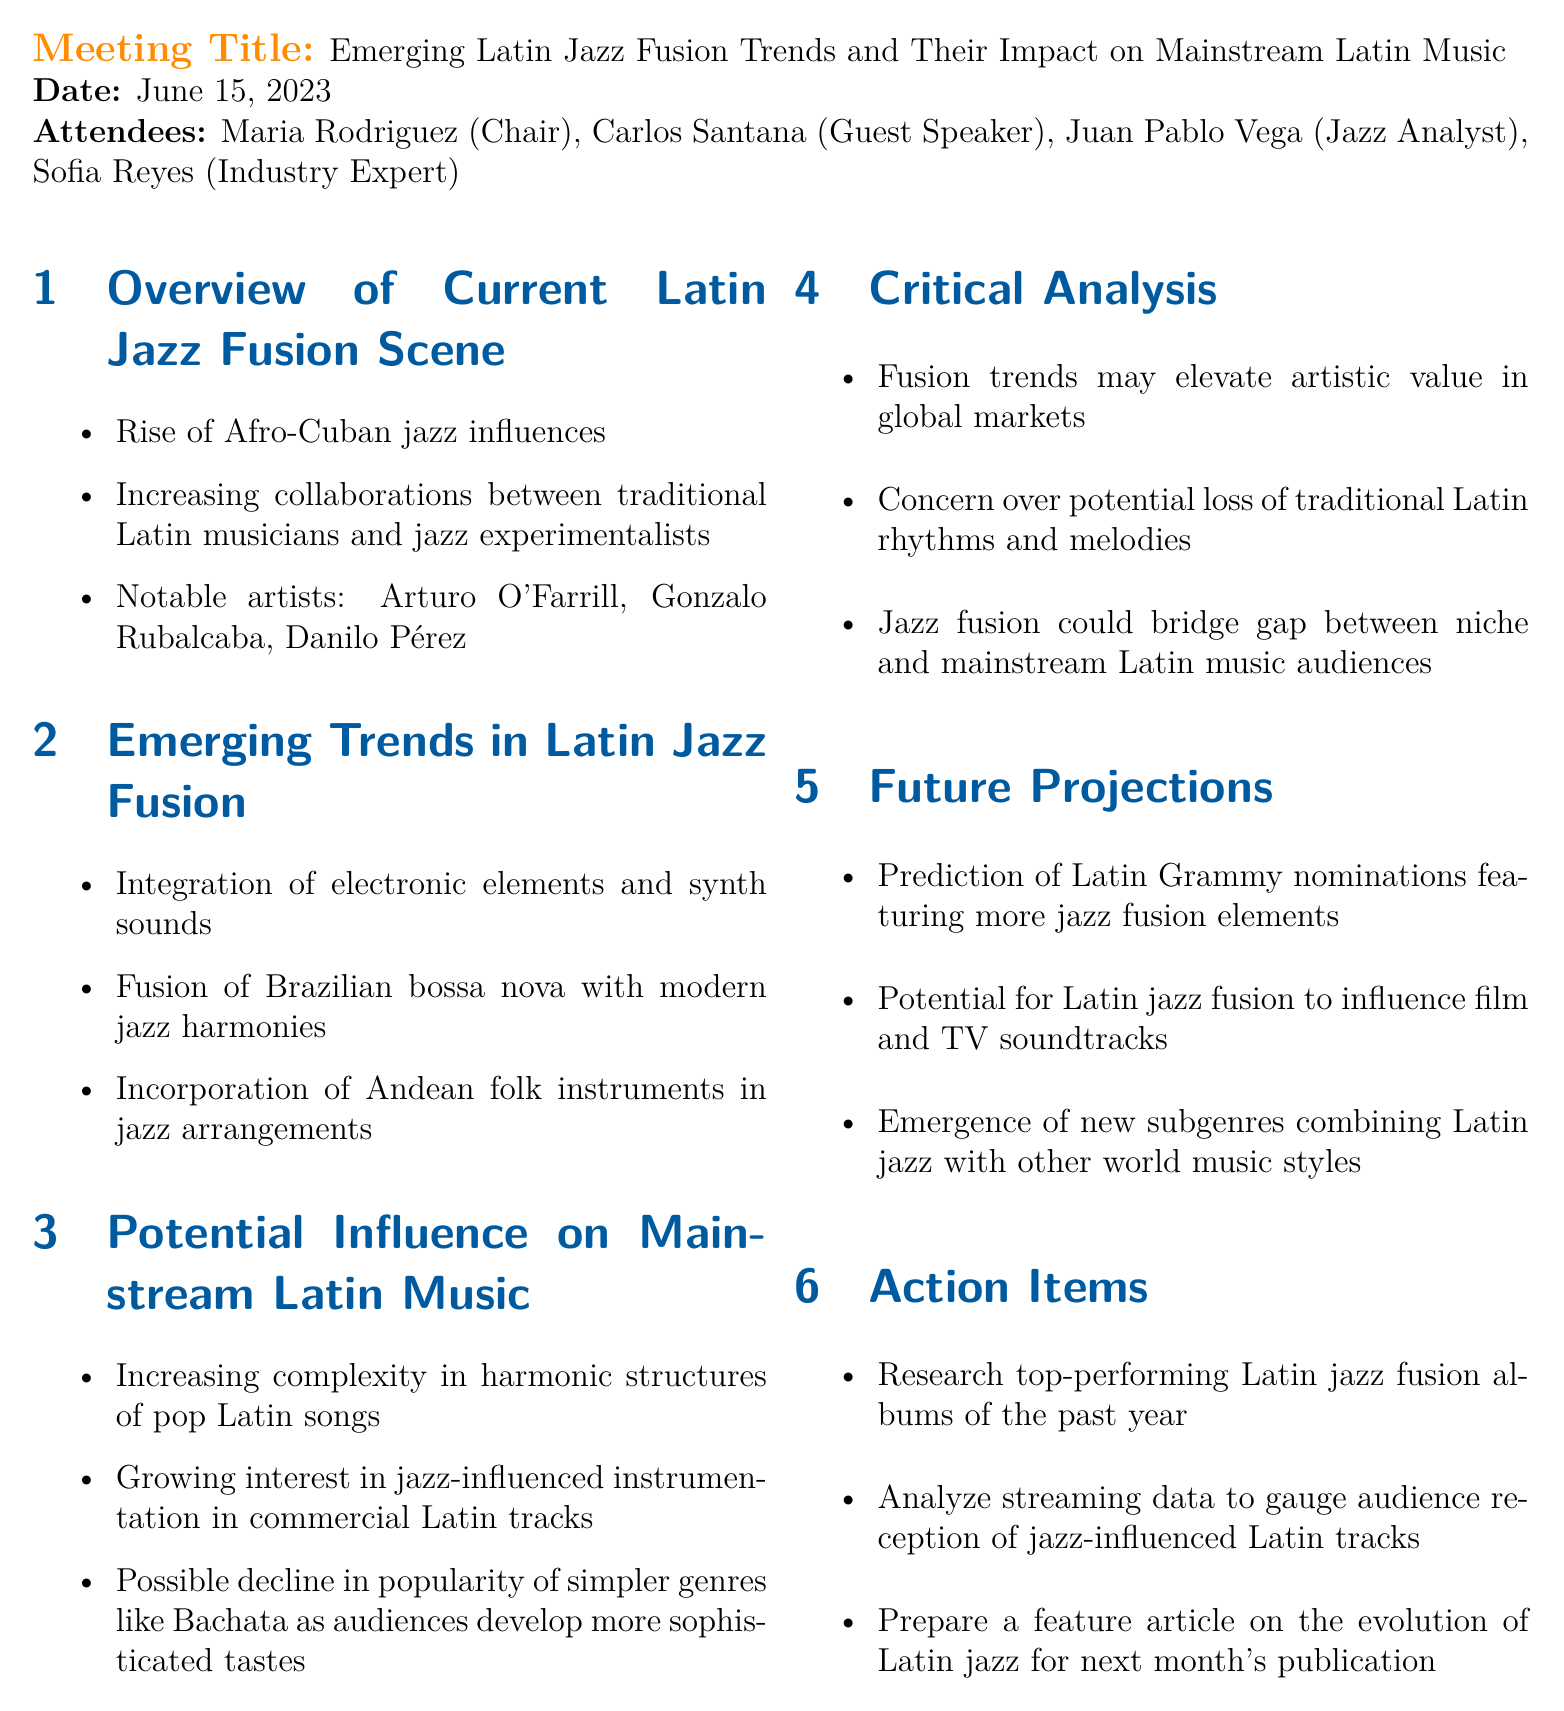what is the meeting title? The meeting title is presented at the beginning of the document, outlining the focus of the discussion.
Answer: Emerging Latin Jazz Fusion Trends and Their Impact on Mainstream Latin Music who was the guest speaker? The guest speaker is mentioned in the attendee list, specifically highlighting their role in the meeting.
Answer: Carlos Santana what is one of the notable artists mentioned in the current Latin jazz fusion scene? The document lists significant artists contributing to the Latin jazz fusion genre during the overview section.
Answer: Arturo O'Farrill what emerging trend involves the use of electronic elements? The document notes specific trends in Latin jazz fusion, including technological influences on composition.
Answer: Integration of electronic elements and synth sounds what is predicted about Latin Grammy nominations? The document makes a future projection regarding the nominations and their relation to jazz fusion elements.
Answer: Featuring more jazz fusion elements what potential decline is discussed in relation to audience tastes? The potential trends affecting genre popularity are analyzed in the document, specifically mentioning certain genres facing decline.
Answer: Bachata what are attendees requested to research as an action item? The action items section outlines specific tasks assigned to attendees for future exploration.
Answer: Top-performing Latin jazz fusion albums of the past year which instruments are incorporated in jazz arrangements as a trend? The document highlights specific cultural influences contributing to the richness of jazz arrangements.
Answer: Andean folk instruments 